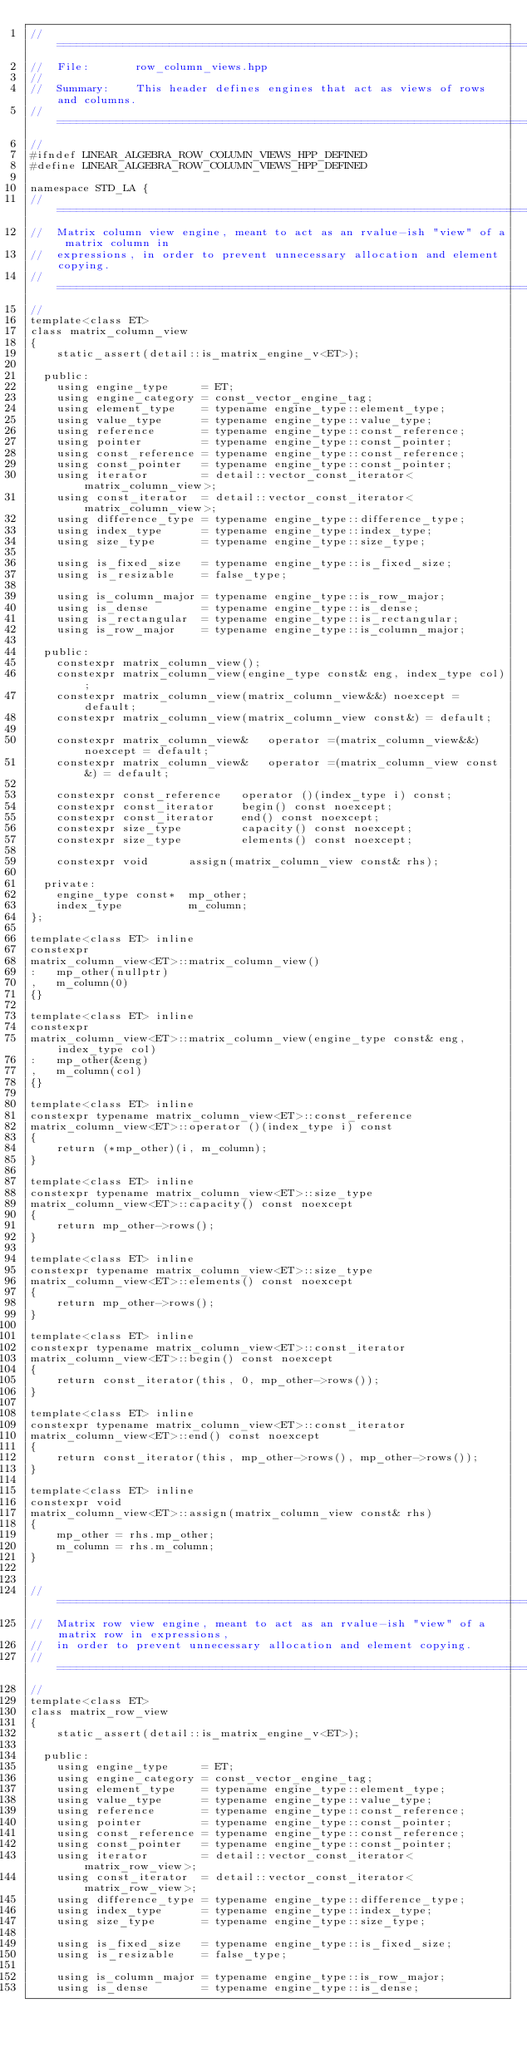Convert code to text. <code><loc_0><loc_0><loc_500><loc_500><_C++_>//==================================================================================================
//  File:       row_column_views.hpp
//
//  Summary:    This header defines engines that act as views of rows and columns.
//==================================================================================================
//
#ifndef LINEAR_ALGEBRA_ROW_COLUMN_VIEWS_HPP_DEFINED
#define LINEAR_ALGEBRA_ROW_COLUMN_VIEWS_HPP_DEFINED

namespace STD_LA {
//==================================================================================================
//  Matrix column view engine, meant to act as an rvalue-ish "view" of a matrix column in 
//  expressions, in order to prevent unnecessary allocation and element copying.
//==================================================================================================
//
template<class ET>
class matrix_column_view
{
    static_assert(detail::is_matrix_engine_v<ET>);

  public:
    using engine_type     = ET;
    using engine_category = const_vector_engine_tag;
    using element_type    = typename engine_type::element_type;
    using value_type      = typename engine_type::value_type;
    using reference       = typename engine_type::const_reference;
    using pointer         = typename engine_type::const_pointer;
    using const_reference = typename engine_type::const_reference;
    using const_pointer   = typename engine_type::const_pointer;
    using iterator        = detail::vector_const_iterator<matrix_column_view>;
    using const_iterator  = detail::vector_const_iterator<matrix_column_view>;
    using difference_type = typename engine_type::difference_type;
    using index_type      = typename engine_type::index_type;
    using size_type       = typename engine_type::size_type;

    using is_fixed_size   = typename engine_type::is_fixed_size;
    using is_resizable    = false_type;

    using is_column_major = typename engine_type::is_row_major;
    using is_dense        = typename engine_type::is_dense;
    using is_rectangular  = typename engine_type::is_rectangular;
    using is_row_major    = typename engine_type::is_column_major;

  public:
    constexpr matrix_column_view();
    constexpr matrix_column_view(engine_type const& eng, index_type col);
    constexpr matrix_column_view(matrix_column_view&&) noexcept = default;
    constexpr matrix_column_view(matrix_column_view const&) = default;

    constexpr matrix_column_view&   operator =(matrix_column_view&&) noexcept = default;
    constexpr matrix_column_view&   operator =(matrix_column_view const&) = default;

    constexpr const_reference   operator ()(index_type i) const;
    constexpr const_iterator    begin() const noexcept;
    constexpr const_iterator    end() const noexcept;
    constexpr size_type         capacity() const noexcept;
    constexpr size_type         elements() const noexcept;

    constexpr void      assign(matrix_column_view const& rhs);

  private:
    engine_type const*  mp_other;
    index_type          m_column;
};

template<class ET> inline 
constexpr
matrix_column_view<ET>::matrix_column_view()
:   mp_other(nullptr)
,   m_column(0)
{}

template<class ET> inline 
constexpr
matrix_column_view<ET>::matrix_column_view(engine_type const& eng, index_type col)
:   mp_other(&eng)
,   m_column(col)
{}

template<class ET> inline 
constexpr typename matrix_column_view<ET>::const_reference
matrix_column_view<ET>::operator ()(index_type i) const
{
    return (*mp_other)(i, m_column);
}

template<class ET> inline 
constexpr typename matrix_column_view<ET>::size_type
matrix_column_view<ET>::capacity() const noexcept
{
    return mp_other->rows();
}

template<class ET> inline 
constexpr typename matrix_column_view<ET>::size_type
matrix_column_view<ET>::elements() const noexcept
{
    return mp_other->rows();
}

template<class ET> inline 
constexpr typename matrix_column_view<ET>::const_iterator
matrix_column_view<ET>::begin() const noexcept
{
    return const_iterator(this, 0, mp_other->rows());
}

template<class ET> inline 
constexpr typename matrix_column_view<ET>::const_iterator
matrix_column_view<ET>::end() const noexcept
{
    return const_iterator(this, mp_other->rows(), mp_other->rows());
}

template<class ET> inline 
constexpr void
matrix_column_view<ET>::assign(matrix_column_view const& rhs)
{
    mp_other = rhs.mp_other;
    m_column = rhs.m_column;
}


//==================================================================================================
//  Matrix row view engine, meant to act as an rvalue-ish "view" of a matrix row in expressions, 
//  in order to prevent unnecessary allocation and element copying.
//==================================================================================================
//
template<class ET>
class matrix_row_view
{
    static_assert(detail::is_matrix_engine_v<ET>);

  public:
    using engine_type     = ET;
    using engine_category = const_vector_engine_tag;
    using element_type    = typename engine_type::element_type;
    using value_type      = typename engine_type::value_type;
    using reference       = typename engine_type::const_reference;
    using pointer         = typename engine_type::const_pointer;
    using const_reference = typename engine_type::const_reference;
    using const_pointer   = typename engine_type::const_pointer;
    using iterator        = detail::vector_const_iterator<matrix_row_view>;
    using const_iterator  = detail::vector_const_iterator<matrix_row_view>;
    using difference_type = typename engine_type::difference_type;
    using index_type      = typename engine_type::index_type;
    using size_type       = typename engine_type::size_type;

    using is_fixed_size   = typename engine_type::is_fixed_size;
    using is_resizable    = false_type;

    using is_column_major = typename engine_type::is_row_major;
    using is_dense        = typename engine_type::is_dense;</code> 